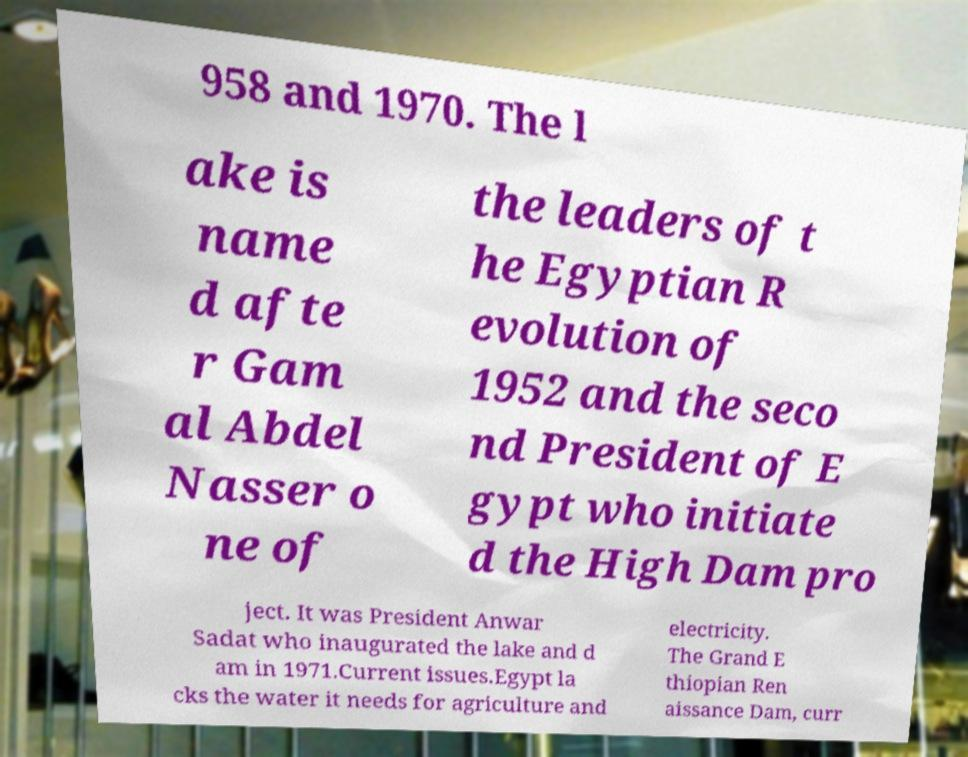What messages or text are displayed in this image? I need them in a readable, typed format. 958 and 1970. The l ake is name d afte r Gam al Abdel Nasser o ne of the leaders of t he Egyptian R evolution of 1952 and the seco nd President of E gypt who initiate d the High Dam pro ject. It was President Anwar Sadat who inaugurated the lake and d am in 1971.Current issues.Egypt la cks the water it needs for agriculture and electricity. The Grand E thiopian Ren aissance Dam, curr 